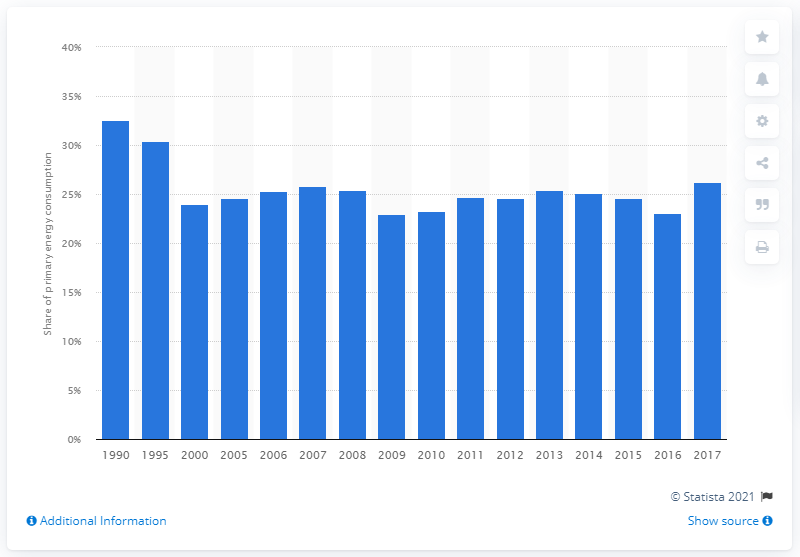Identify some key points in this picture. In 2017, renewable energy accounted for 26.2% of Colombia's primary energy consumption. 